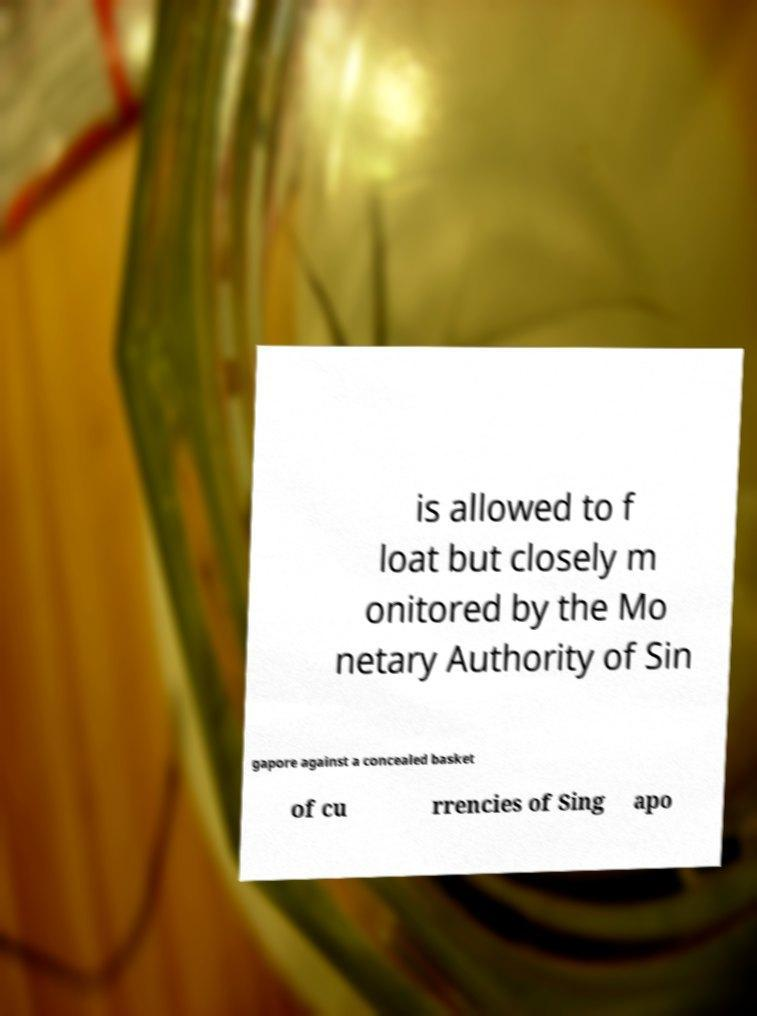For documentation purposes, I need the text within this image transcribed. Could you provide that? is allowed to f loat but closely m onitored by the Mo netary Authority of Sin gapore against a concealed basket of cu rrencies of Sing apo 